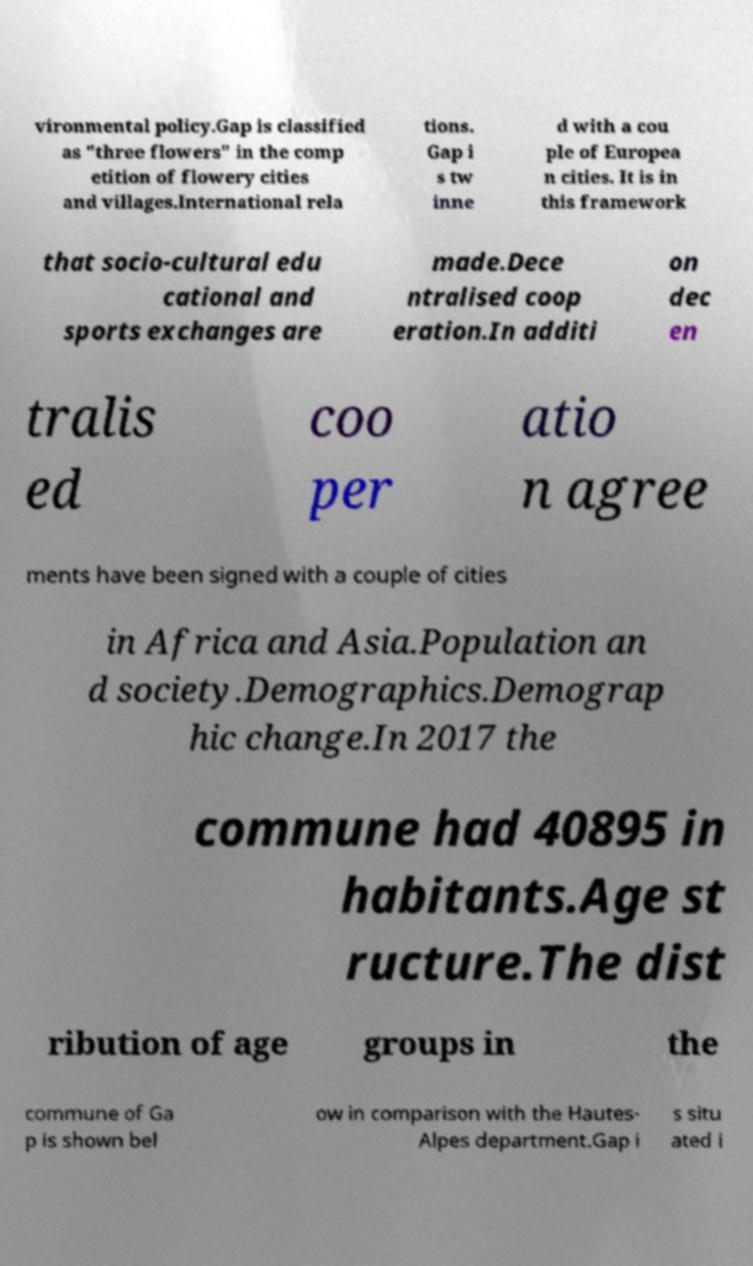Could you assist in decoding the text presented in this image and type it out clearly? vironmental policy.Gap is classified as "three flowers" in the comp etition of flowery cities and villages.International rela tions. Gap i s tw inne d with a cou ple of Europea n cities. It is in this framework that socio-cultural edu cational and sports exchanges are made.Dece ntralised coop eration.In additi on dec en tralis ed coo per atio n agree ments have been signed with a couple of cities in Africa and Asia.Population an d society.Demographics.Demograp hic change.In 2017 the commune had 40895 in habitants.Age st ructure.The dist ribution of age groups in the commune of Ga p is shown bel ow in comparison with the Hautes- Alpes department.Gap i s situ ated i 